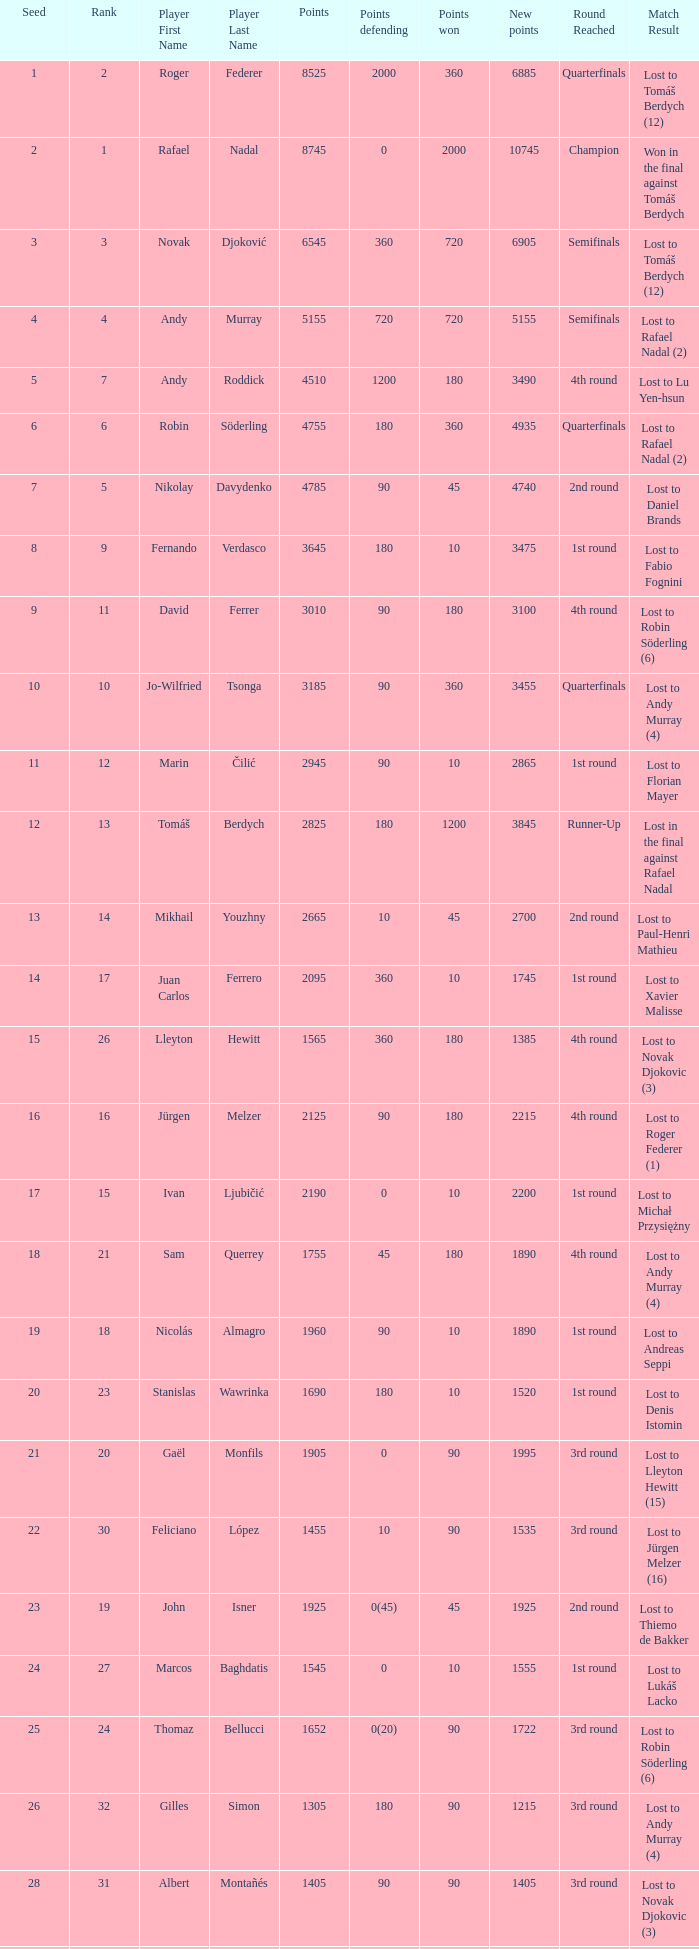Name the least new points for points defending is 1200 3490.0. 